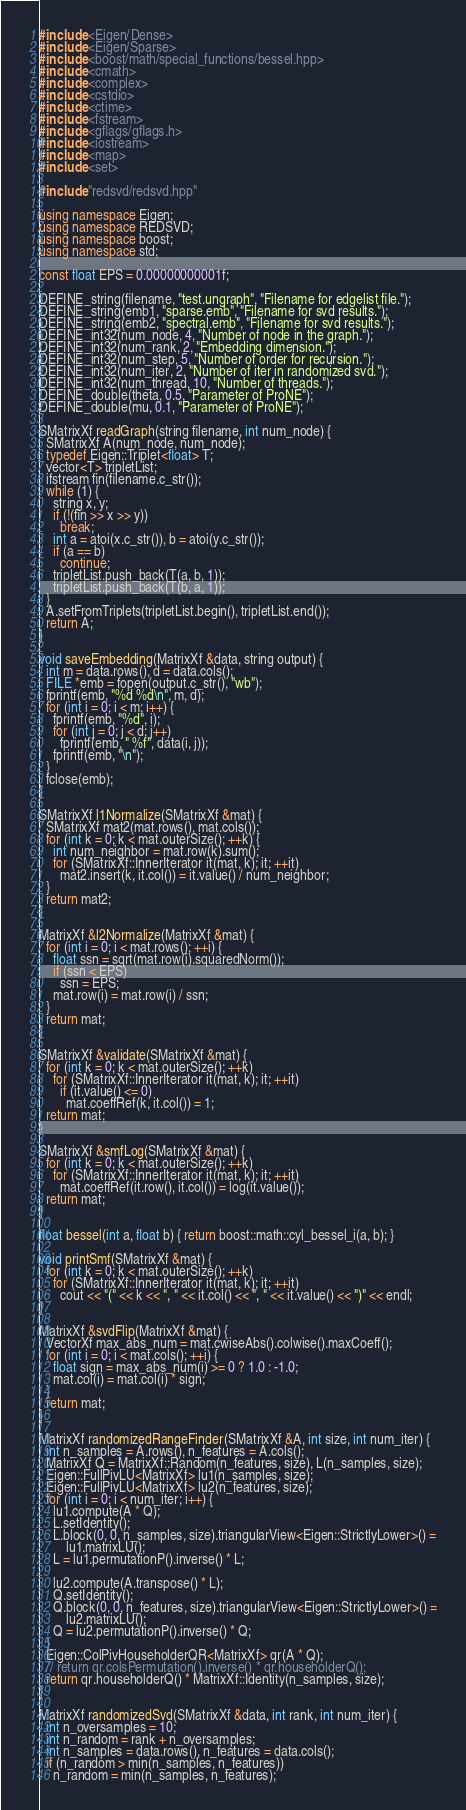<code> <loc_0><loc_0><loc_500><loc_500><_C++_>#include <Eigen/Dense>
#include <Eigen/Sparse>
#include <boost/math/special_functions/bessel.hpp>
#include <cmath>
#include <complex>
#include <cstdio>
#include <ctime>
#include <fstream>
#include <gflags/gflags.h>
#include <iostream>
#include <map>
#include <set>

#include "redsvd/redsvd.hpp"

using namespace Eigen;
using namespace REDSVD;
using namespace boost;
using namespace std;

const float EPS = 0.00000000001f;

DEFINE_string(filename, "test.ungraph", "Filename for edgelist file.");
DEFINE_string(emb1, "sparse.emb", "Filename for svd results.");
DEFINE_string(emb2, "spectral.emb", "Filename for svd results.");
DEFINE_int32(num_node, 4, "Number of node in the graph.");
DEFINE_int32(num_rank, 2, "Embedding dimension.");
DEFINE_int32(num_step, 5, "Number of order for recursion.");
DEFINE_int32(num_iter, 2, "Number of iter in randomized svd.");
DEFINE_int32(num_thread, 10, "Number of threads.");
DEFINE_double(theta, 0.5, "Parameter of ProNE");
DEFINE_double(mu, 0.1, "Parameter of ProNE");

SMatrixXf readGraph(string filename, int num_node) {
  SMatrixXf A(num_node, num_node);
  typedef Eigen::Triplet<float> T;
  vector<T> tripletList;
  ifstream fin(filename.c_str());
  while (1) {
    string x, y;
    if (!(fin >> x >> y))
      break;
    int a = atoi(x.c_str()), b = atoi(y.c_str());
    if (a == b)
      continue;
    tripletList.push_back(T(a, b, 1));
    tripletList.push_back(T(b, a, 1));
  }
  A.setFromTriplets(tripletList.begin(), tripletList.end());
  return A;
}

void saveEmbedding(MatrixXf &data, string output) {
  int m = data.rows(), d = data.cols();
  FILE *emb = fopen(output.c_str(), "wb");
  fprintf(emb, "%d %d\n", m, d);
  for (int i = 0; i < m; i++) {
    fprintf(emb, "%d", i);
    for (int j = 0; j < d; j++)
      fprintf(emb, " %f", data(i, j));
    fprintf(emb, "\n");
  }
  fclose(emb);
}

SMatrixXf l1Normalize(SMatrixXf &mat) {
  SMatrixXf mat2(mat.rows(), mat.cols());
  for (int k = 0; k < mat.outerSize(); ++k) {
    int num_neighbor = mat.row(k).sum();
    for (SMatrixXf::InnerIterator it(mat, k); it; ++it)
      mat2.insert(k, it.col()) = it.value() / num_neighbor;
  }
  return mat2;
}

MatrixXf &l2Normalize(MatrixXf &mat) {
  for (int i = 0; i < mat.rows(); ++i) {
    float ssn = sqrt(mat.row(i).squaredNorm());
    if (ssn < EPS)
      ssn = EPS;
    mat.row(i) = mat.row(i) / ssn;
  }
  return mat;
}

SMatrixXf &validate(SMatrixXf &mat) {
  for (int k = 0; k < mat.outerSize(); ++k)
    for (SMatrixXf::InnerIterator it(mat, k); it; ++it)
      if (it.value() <= 0)
        mat.coeffRef(k, it.col()) = 1;
  return mat;
}

SMatrixXf &smfLog(SMatrixXf &mat) {
  for (int k = 0; k < mat.outerSize(); ++k)
    for (SMatrixXf::InnerIterator it(mat, k); it; ++it)
      mat.coeffRef(it.row(), it.col()) = log(it.value());
  return mat;
}

float bessel(int a, float b) { return boost::math::cyl_bessel_i(a, b); }

void printSmf(SMatrixXf &mat) {
  for (int k = 0; k < mat.outerSize(); ++k)
    for (SMatrixXf::InnerIterator it(mat, k); it; ++it)
      cout << "(" << k << ", " << it.col() << ", " << it.value() << ")" << endl;
}

MatrixXf &svdFlip(MatrixXf &mat) {
  VectorXf max_abs_num = mat.cwiseAbs().colwise().maxCoeff();
  for (int i = 0; i < mat.cols(); ++i) {
    float sign = max_abs_num(i) >= 0 ? 1.0 : -1.0;
    mat.col(i) = mat.col(i) * sign;
  }
  return mat;
}

MatrixXf randomizedRangeFinder(SMatrixXf &A, int size, int num_iter) {
  int n_samples = A.rows(), n_features = A.cols();
  MatrixXf Q = MatrixXf::Random(n_features, size), L(n_samples, size);
  Eigen::FullPivLU<MatrixXf> lu1(n_samples, size);
  Eigen::FullPivLU<MatrixXf> lu2(n_features, size);
  for (int i = 0; i < num_iter; i++) {
    lu1.compute(A * Q);
    L.setIdentity();
    L.block(0, 0, n_samples, size).triangularView<Eigen::StrictlyLower>() =
        lu1.matrixLU();
    L = lu1.permutationP().inverse() * L;

    lu2.compute(A.transpose() * L);
    Q.setIdentity();
    Q.block(0, 0, n_features, size).triangularView<Eigen::StrictlyLower>() =
        lu2.matrixLU();
    Q = lu2.permutationP().inverse() * Q;
  }
  Eigen::ColPivHouseholderQR<MatrixXf> qr(A * Q);
  // return qr.colsPermutation().inverse() * qr.householderQ();
  return qr.householderQ() * MatrixXf::Identity(n_samples, size);
}

MatrixXf randomizedSvd(SMatrixXf &data, int rank, int num_iter) {
  int n_oversamples = 10;
  int n_random = rank + n_oversamples;
  int n_samples = data.rows(), n_features = data.cols();
  if (n_random > min(n_samples, n_features))
    n_random = min(n_samples, n_features);
</code> 